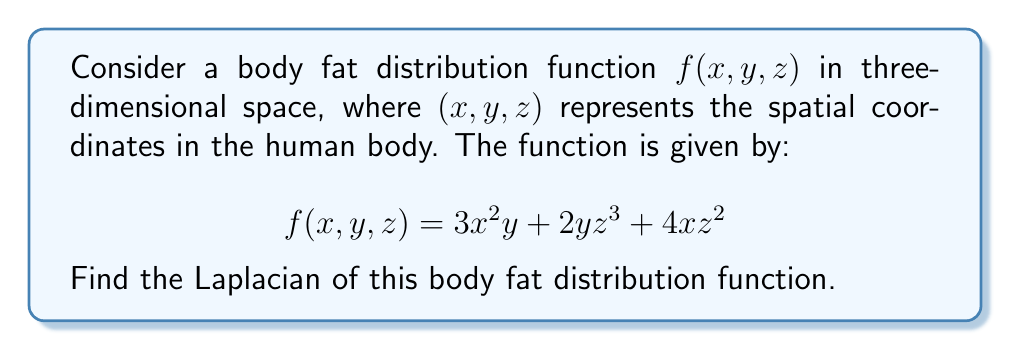Provide a solution to this math problem. To find the Laplacian of the body fat distribution function, we need to calculate the sum of the second partial derivatives with respect to each variable. The Laplacian in three dimensions is given by:

$$\nabla^2f = \frac{\partial^2f}{\partial x^2} + \frac{\partial^2f}{\partial y^2} + \frac{\partial^2f}{\partial z^2}$$

Let's calculate each term separately:

1. $\frac{\partial^2f}{\partial x^2}$:
   First, $\frac{\partial f}{\partial x} = 6xy + 4z^2$
   Then, $\frac{\partial^2f}{\partial x^2} = 6y$

2. $\frac{\partial^2f}{\partial y^2}$:
   First, $\frac{\partial f}{\partial y} = 3x^2 + 2z^3$
   Then, $\frac{\partial^2f}{\partial y^2} = 0$

3. $\frac{\partial^2f}{\partial z^2}$:
   First, $\frac{\partial f}{\partial z} = 6yz^2 + 8xz$
   Then, $\frac{\partial^2f}{\partial z^2} = 12yz + 8x$

Now, we sum these three terms to get the Laplacian:

$$\nabla^2f = 6y + 0 + 12yz + 8x = 8x + 6y + 12yz$$

This is the Laplacian of the given body fat distribution function.
Answer: $\nabla^2f = 8x + 6y + 12yz$ 